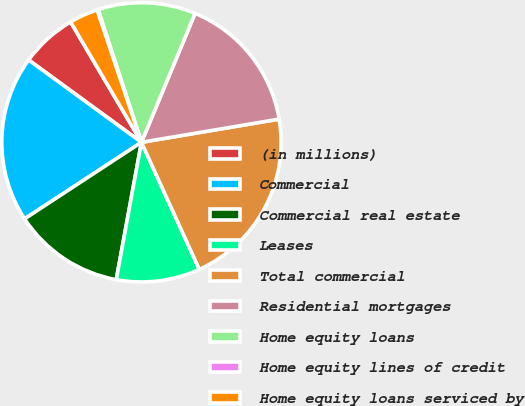Convert chart to OTSL. <chart><loc_0><loc_0><loc_500><loc_500><pie_chart><fcel>(in millions)<fcel>Commercial<fcel>Commercial real estate<fcel>Leases<fcel>Total commercial<fcel>Residential mortgages<fcel>Home equity loans<fcel>Home equity lines of credit<fcel>Home equity loans serviced by<nl><fcel>6.5%<fcel>19.26%<fcel>12.88%<fcel>9.69%<fcel>20.85%<fcel>16.07%<fcel>11.29%<fcel>0.13%<fcel>3.32%<nl></chart> 